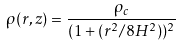<formula> <loc_0><loc_0><loc_500><loc_500>\rho ( r , z ) = \frac { \rho _ { c } } { ( 1 + ( r ^ { 2 } / 8 H ^ { 2 } ) ) ^ { 2 } }</formula> 